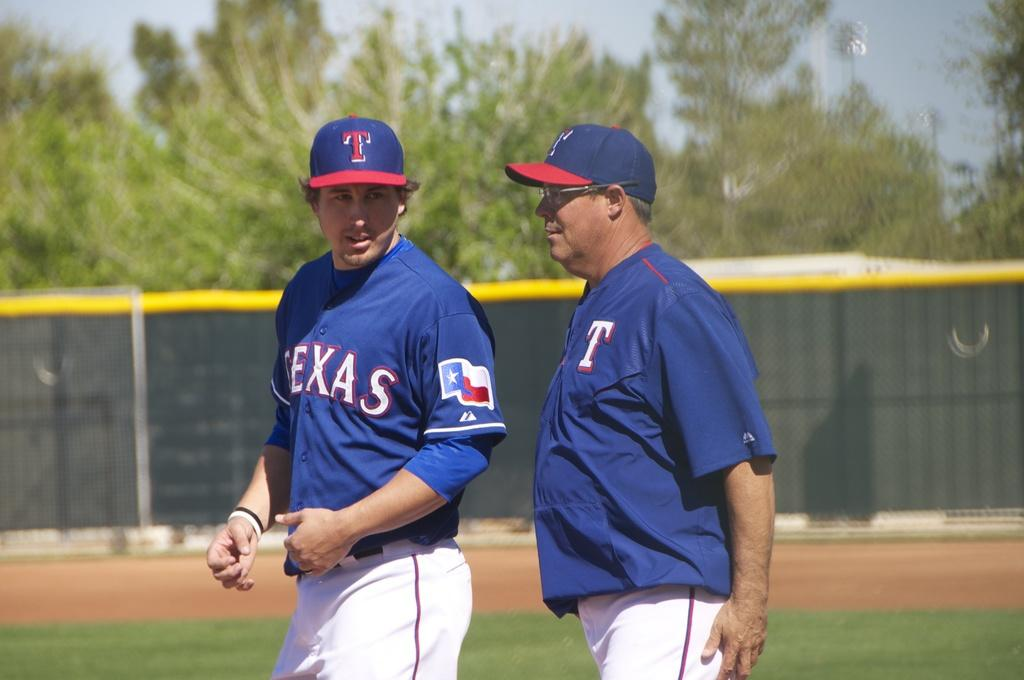Provide a one-sentence caption for the provided image. A member of the Texas team talks to a coach on the field. 